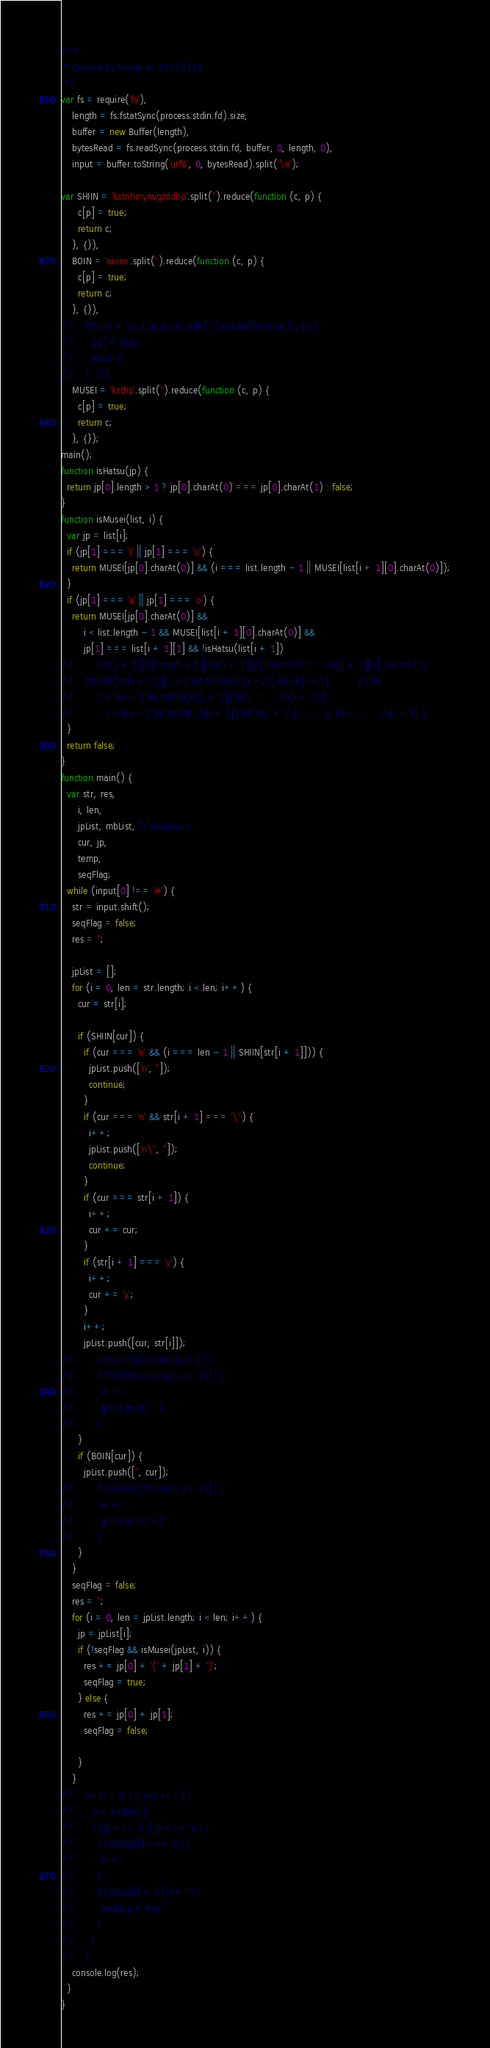Convert code to text. <code><loc_0><loc_0><loc_500><loc_500><_JavaScript_>/**
 * Created by hiroqn on 13/10/11.
 */
var fs = require('fs'),
    length = fs.fstatSync(process.stdin.fd).size,
    buffer = new Buffer(length),
    bytesRead = fs.readSync(process.stdin.fd, buffer, 0, length, 0),
    input = buffer.toString('utf8', 0, bytesRead).split('\n');

var SHIIN = 'kstnhmyrwgzddbp'.split('').reduce(function (c, p) {
      c[p] = true;
      return c;
    }, {}),
    BOIN = 'aiueo'.split('').reduce(function (c, p) {
      c[p] = true;
      return c;
    }, {}),
//    TYOUIN = 'aa,ii,uu,ei,ou'.split(',').reduce(function (c, p) {
//      c[p] = true;
//      return c;
//    }, {}),
    MUSEI = 'ksthp'.split('').reduce(function (c, p) {
      c[p] = true;
      return c;
    }, {});
main();
function isHatsu(jp) {
  return jp[0].length > 1 ? jp[0].charAt(0) === jp[0].charAt(1) : false;
}
function isMusei(list, i) {
  var jp = list[i];
  if (jp[1] === 'i' || jp[1] === 'u') {
    return MUSEI[jp[0].charAt(0)] && (i === list.length - 1 || MUSEI[list[i + 1][0].charAt(0)]);
  }
  if (jp[1] === 'a' || jp[1] === 'o') {
    return MUSEI[jp[0].charAt(0)] &&
        i < list.length - 1 && MUSEI[list[i + 1][0].charAt(0)] &&
        jp[1] === list[i + 1][1] && !isHatsu(list[i + 1])
//        (list[i + 1][0].length > 1 || list[i + 1][0].charAt(0) !== list[i + 1][0].charAt(1))
//    (MUSEI[str[i - 1]] || i > 1 && MUSEI[str[i - 2]] && str[i - 1] === 'y') &&
//        (i < len - 2 && MUSEI[str[i + 1]] && c === str[i + 2] ||
//            i < len - 3 && MUSEI[str[i + 1]] && str[i + 2 ] === 'y' && c === str[i + 3] )
  }
  return false;
}
function main() {
  var str, res,
      i, len,
      jpList, mbList,//museiboin
      cur, jp,
      temp,
      seqFlag;
  while (input[0] !== '#') {
    str = input.shift();
    seqFlag = false;
    res = '';

    jpList = [];
    for (i = 0, len = str.length; i < len; i++) {
      cur = str[i];

      if (SHIIN[cur]) {
        if (cur === 'n' && (i === len - 1 || SHIIN[str[i + 1]])) {
          jpList.push(['n', '']);
          continue;
        }
        if (cur === 'n' && str[i + 1] === '\'') {
          i++;
          jpList.push(['n\'', '']);
          continue;
        }
        if (cur === str[i + 1]) {
          i++;
          cur += cur;
        }
        if (str[i + 1] === 'y') {
          i++;
          cur += 'y';
        }
        i++;
        jpList.push([cur, str[i]]);
//        console.log(str.slice(i,i+2));
//        if (TYOUIN[str.slice(i, i + 2)]) {
//          i++;
//          jpList.push('-');
//        }
      }
      if (BOIN[cur]) {
        jpList.push(['', cur]);
//        if (TYOUIN[str.slice(i, i + 2)]) {
//          i++;
//          jpList.push('-');
//        }
      }
    }
    seqFlag = false;
    res = '';
    for (i = 0, len = jpList.length; i < len; i++) {
      jp = jpList[i];
      if (!seqFlag && isMusei(jpList, i)) {
        res += jp[0] + '(' + jp[1] + ')';
        seqFlag = true;
      } else {
        res += jp[0] + jp[1];
        seqFlag = false;

      }
    }
//    for (i = 0; i < len; i++) {
//      jp = mbList[i];
//      if (jp === 'i' || jp === 'u') {
//        if (mbList[i] === 'x') {
//          i++;
//        }
//        if (mbList[i + 1] !== '') {
//          seqFlag = true;
//        }
//      }
//    }
    console.log(res);
  }
}</code> 